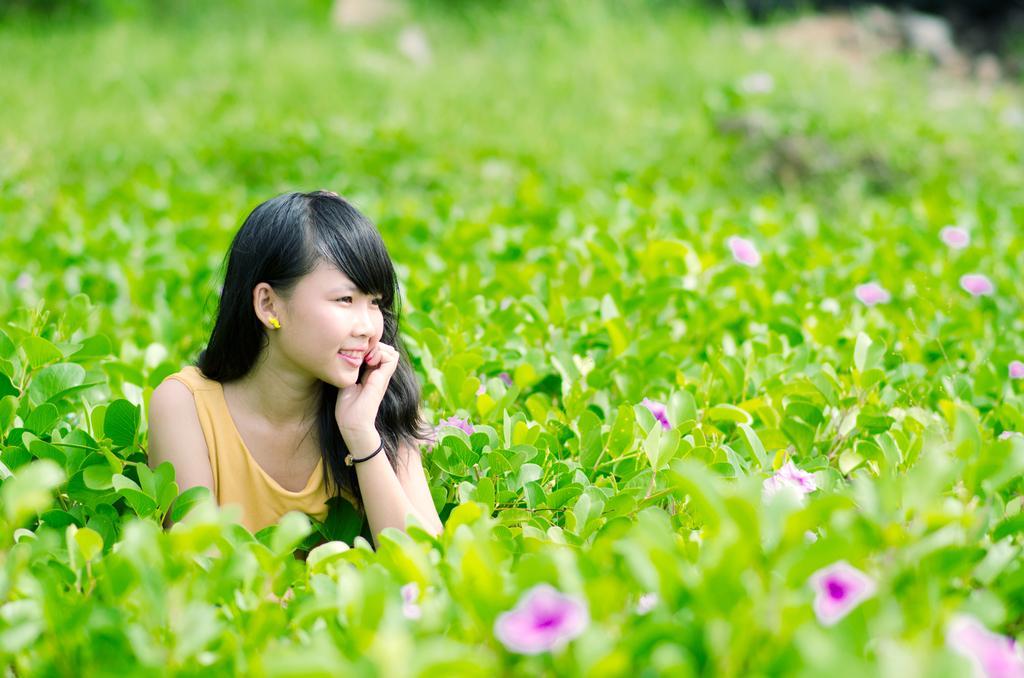Please provide a concise description of this image. In the picture I can see a woman on the left side and there is a pretty smile on her face. I can see the flowering plants and green leaves. 